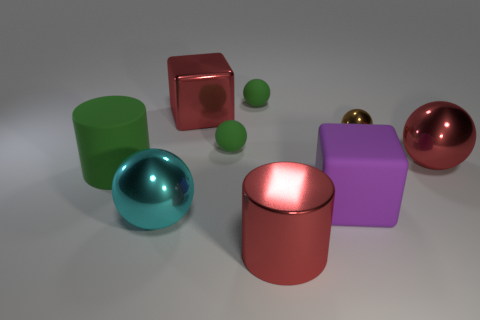Subtract all small matte spheres. How many spheres are left? 3 Subtract all red balls. How many balls are left? 4 Subtract all purple blocks. How many green balls are left? 2 Subtract 3 spheres. How many spheres are left? 2 Add 1 brown balls. How many objects exist? 10 Subtract all cubes. How many objects are left? 7 Add 2 cubes. How many cubes exist? 4 Subtract 0 brown cubes. How many objects are left? 9 Subtract all purple spheres. Subtract all purple cylinders. How many spheres are left? 5 Subtract all tiny green balls. Subtract all tiny brown things. How many objects are left? 6 